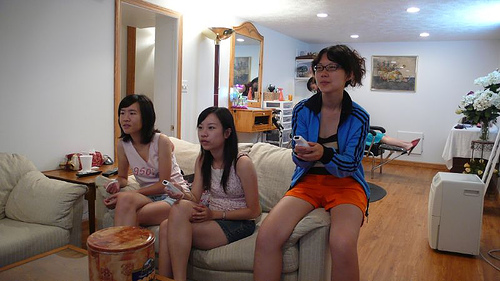Extract all visible text content from this image. 950 